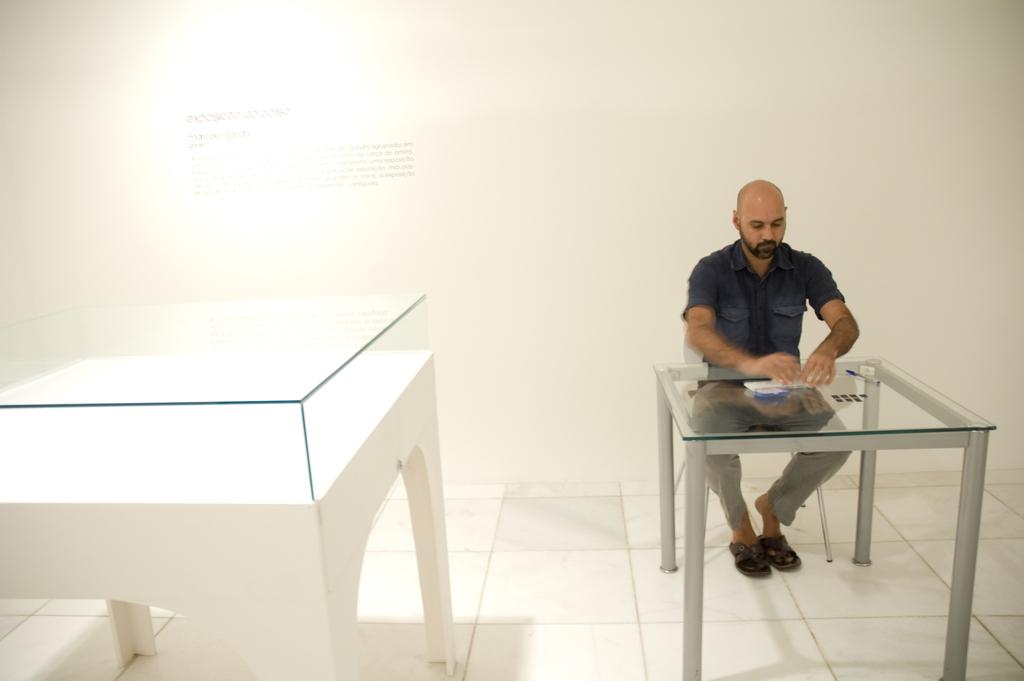What is the man in the image doing? The man is sitting on a chair in the image. What is in front of the man? There is a table in front of the man. What object is placed on the table? A glass box is placed on the table. What can be seen in the background of the image? There is a wall visible in the background of the image. What type of apples are being grown on the farm in the image? There is no farm or apples present in the image; it features a man sitting on a chair with a table and a glass box. 